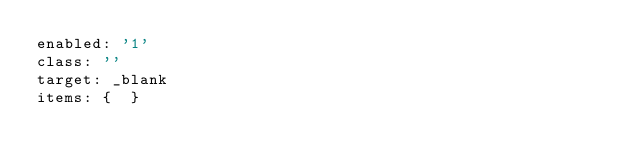Convert code to text. <code><loc_0><loc_0><loc_500><loc_500><_YAML_>enabled: '1'
class: ''
target: _blank
items: {  }
</code> 